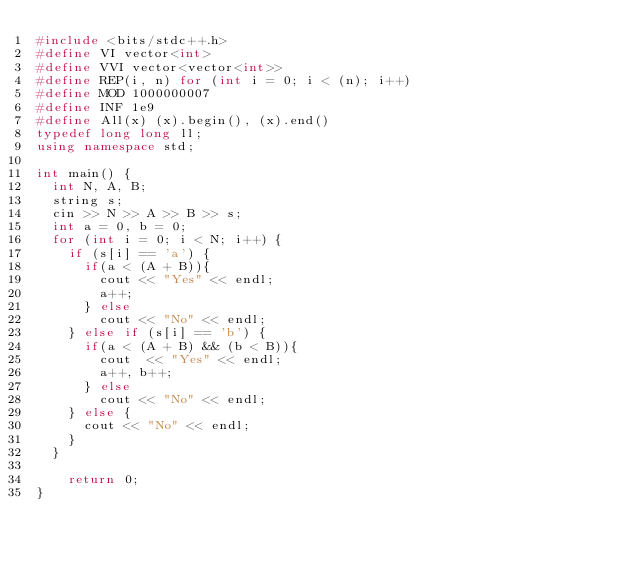Convert code to text. <code><loc_0><loc_0><loc_500><loc_500><_C++_>#include <bits/stdc++.h>
#define VI vector<int>
#define VVI vector<vector<int>>
#define REP(i, n) for (int i = 0; i < (n); i++)
#define MOD 1000000007
#define INF 1e9
#define All(x) (x).begin(), (x).end()
typedef long long ll;
using namespace std;

int main() {
  int N, A, B;
  string s;
  cin >> N >> A >> B >> s;
  int a = 0, b = 0;
  for (int i = 0; i < N; i++) {
    if (s[i] == 'a') {
      if(a < (A + B)){
        cout << "Yes" << endl;
        a++;
      } else
        cout << "No" << endl;
    } else if (s[i] == 'b') {
      if(a < (A + B) && (b < B)){
        cout  << "Yes" << endl;
        a++, b++;
      } else
        cout << "No" << endl;
    } else {
      cout << "No" << endl;
    }
  }

    return 0;
}</code> 